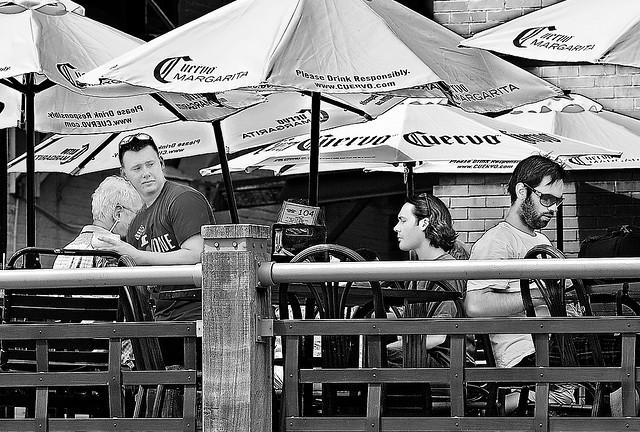What brand of tequila is advertised?
Keep it brief. Cuervo. How many people are there?
Answer briefly. 4. How many people have beards?
Short answer required. 1. 